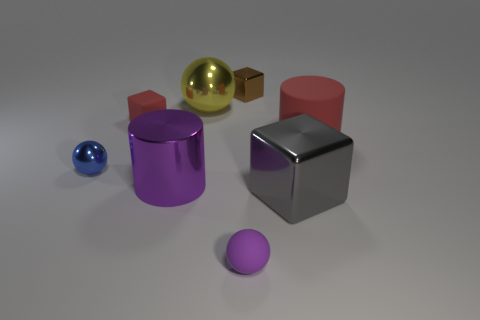Subtract all small spheres. How many spheres are left? 1 Add 1 brown metallic cubes. How many objects exist? 9 Subtract all green blocks. Subtract all yellow balls. How many blocks are left? 3 Subtract all cylinders. How many objects are left? 6 Subtract 0 brown spheres. How many objects are left? 8 Subtract all tiny spheres. Subtract all red matte cubes. How many objects are left? 5 Add 6 small blue things. How many small blue things are left? 7 Add 3 large red matte things. How many large red matte things exist? 4 